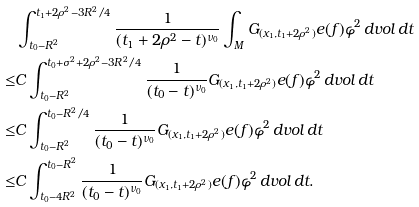<formula> <loc_0><loc_0><loc_500><loc_500>& \int _ { t _ { 0 } - R ^ { 2 } } ^ { t _ { 1 } + 2 \rho ^ { 2 } - 3 R ^ { 2 } / 4 } \frac { 1 } { ( t _ { 1 } + 2 \rho ^ { 2 } - t ) ^ { \nu _ { 0 } } } \int _ { M } G _ { ( x _ { 1 } , t _ { 1 } + 2 \rho ^ { 2 } ) } e ( f ) \varphi ^ { 2 } \, d v o l \, d t \\ \leq & C \int _ { t _ { 0 } - R ^ { 2 } } ^ { t _ { 0 } + \sigma ^ { 2 } + 2 \rho ^ { 2 } - 3 R ^ { 2 } / 4 } \frac { 1 } { ( t _ { 0 } - t ) ^ { \nu _ { 0 } } } G _ { ( x _ { 1 } , t _ { 1 } + 2 \rho ^ { 2 } ) } e ( f ) \varphi ^ { 2 } \, d v o l \, d t \\ \leq & C \int _ { t _ { 0 } - R ^ { 2 } } ^ { t _ { 0 } - R ^ { 2 } / 4 } \frac { 1 } { ( t _ { 0 } - t ) ^ { \nu _ { 0 } } } G _ { ( x _ { 1 } , t _ { 1 } + 2 \rho ^ { 2 } ) } e ( f ) \varphi ^ { 2 } \, d v o l \, d t \\ \leq & C \int _ { t _ { 0 } - 4 R ^ { 2 } } ^ { t _ { 0 } - R ^ { 2 } } \frac { 1 } { ( t _ { 0 } - t ) ^ { \nu _ { 0 } } } G _ { ( x _ { 1 } , t _ { 1 } + 2 \rho ^ { 2 } ) } e ( f ) \varphi ^ { 2 } \, d v o l \, d t .</formula> 